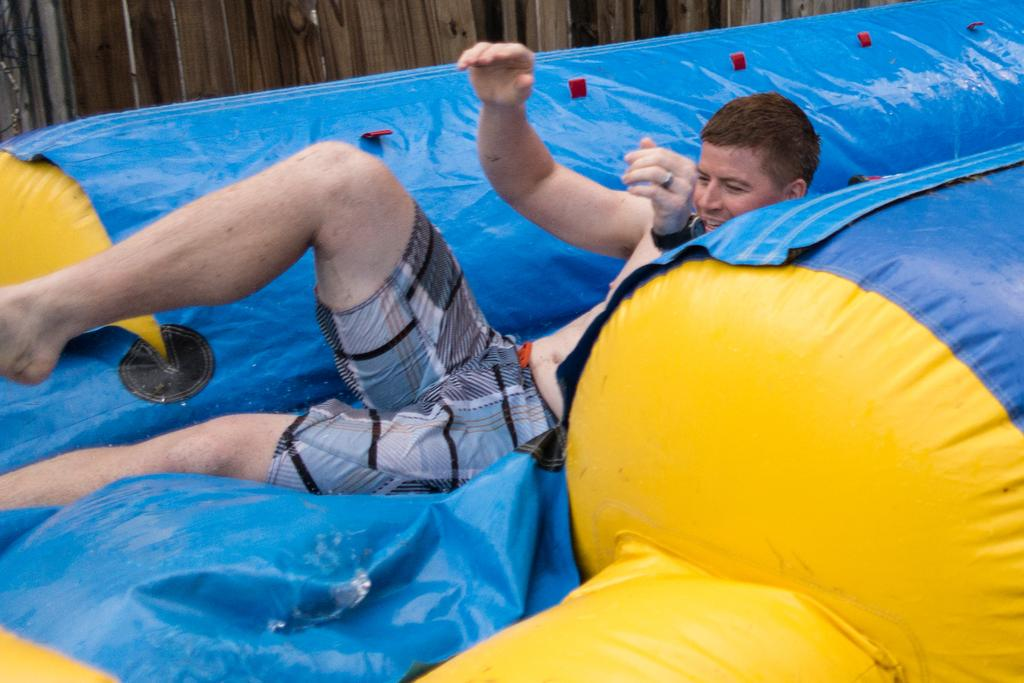Who is present in the image? There is a man in the image. What is the man doing in the image? The man is on an object. Can you describe the object the man is on? The object is yellow and blue in color. What can be seen in the background of the image? There is a wooden fence in the background of the image. What type of throat lozenges can be seen in the image? There are no throat lozenges present in the image. Can you point out the map in the image? There is no map present in the image. 